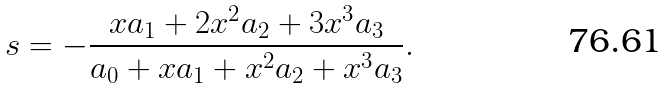Convert formula to latex. <formula><loc_0><loc_0><loc_500><loc_500>s = - \frac { x a _ { 1 } + 2 x ^ { 2 } a _ { 2 } + 3 x ^ { 3 } a _ { 3 } } { a _ { 0 } + x a _ { 1 } + x ^ { 2 } a _ { 2 } + x ^ { 3 } a _ { 3 } } .</formula> 